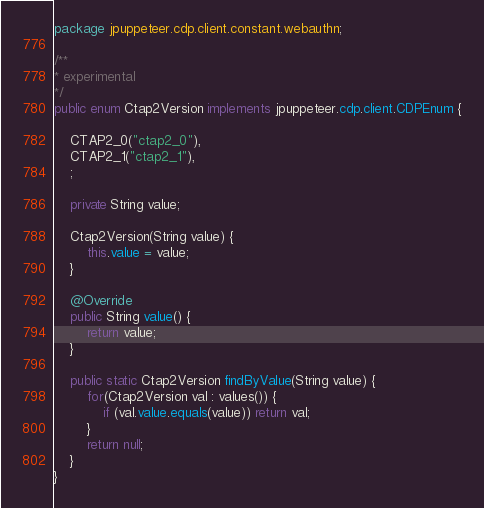Convert code to text. <code><loc_0><loc_0><loc_500><loc_500><_Java_>package jpuppeteer.cdp.client.constant.webauthn;

/**
* experimental
*/
public enum Ctap2Version implements jpuppeteer.cdp.client.CDPEnum {

    CTAP2_0("ctap2_0"),
    CTAP2_1("ctap2_1"),
    ;

    private String value;

    Ctap2Version(String value) {
        this.value = value;
    }

    @Override
    public String value() {
        return value;
    }

    public static Ctap2Version findByValue(String value) {
        for(Ctap2Version val : values()) {
            if (val.value.equals(value)) return val;
        }
        return null;
    }
}</code> 